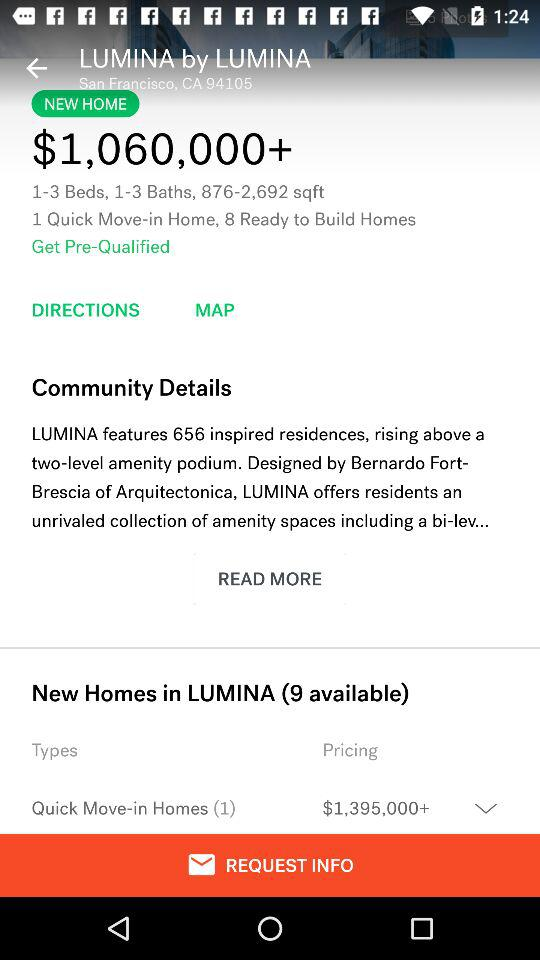What is the location? The location is San Francisco, CA. 